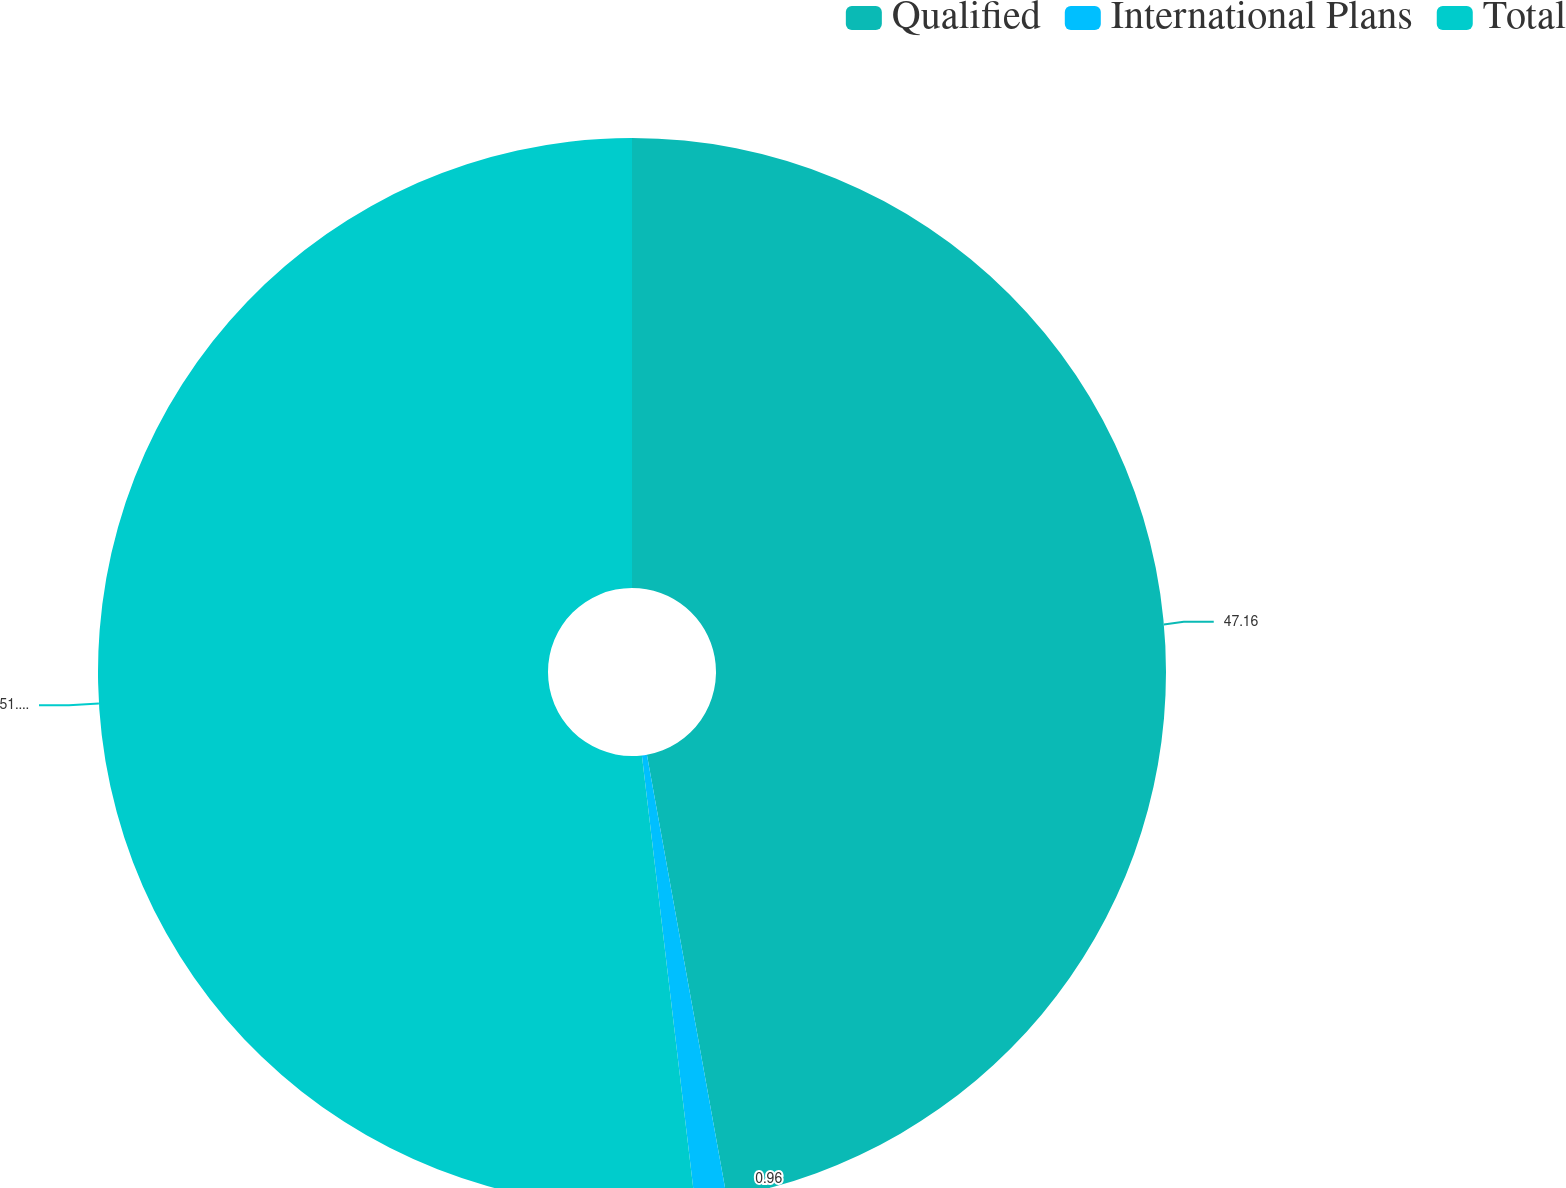Convert chart. <chart><loc_0><loc_0><loc_500><loc_500><pie_chart><fcel>Qualified<fcel>International Plans<fcel>Total<nl><fcel>47.16%<fcel>0.96%<fcel>51.88%<nl></chart> 